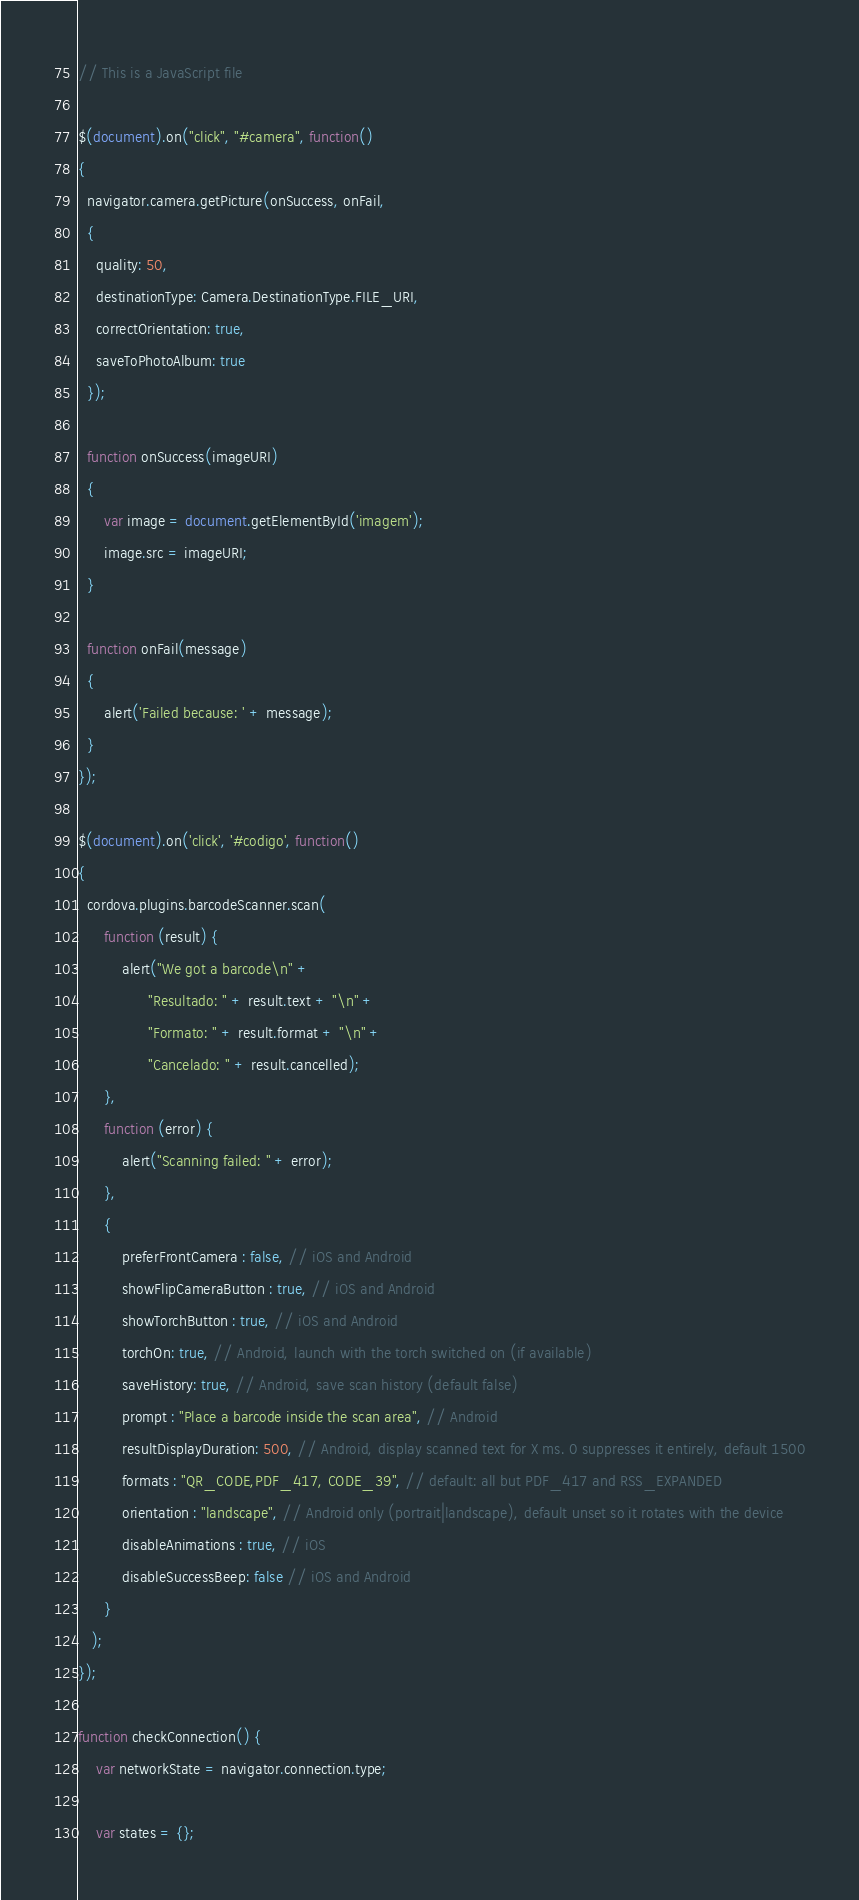Convert code to text. <code><loc_0><loc_0><loc_500><loc_500><_JavaScript_>// This is a JavaScript file

$(document).on("click", "#camera", function()
{
  navigator.camera.getPicture(onSuccess, onFail, 
  { 
    quality: 50,
    destinationType: Camera.DestinationType.FILE_URI,
    correctOrientation: true,
    saveToPhotoAlbum: true
  });

  function onSuccess(imageURI) 
  {
      var image = document.getElementById('imagem');
      image.src = imageURI;
  }

  function onFail(message) 
  {
      alert('Failed because: ' + message);
  }
});

$(document).on('click', '#codigo', function()
{
  cordova.plugins.barcodeScanner.scan(
      function (result) {
          alert("We got a barcode\n" +
                "Resultado: " + result.text + "\n" +
                "Formato: " + result.format + "\n" +
                "Cancelado: " + result.cancelled);
      },
      function (error) {
          alert("Scanning failed: " + error);
      },
      {
          preferFrontCamera : false, // iOS and Android
          showFlipCameraButton : true, // iOS and Android
          showTorchButton : true, // iOS and Android
          torchOn: true, // Android, launch with the torch switched on (if available)
          saveHistory: true, // Android, save scan history (default false)
          prompt : "Place a barcode inside the scan area", // Android
          resultDisplayDuration: 500, // Android, display scanned text for X ms. 0 suppresses it entirely, default 1500
          formats : "QR_CODE,PDF_417, CODE_39", // default: all but PDF_417 and RSS_EXPANDED
          orientation : "landscape", // Android only (portrait|landscape), default unset so it rotates with the device
          disableAnimations : true, // iOS
          disableSuccessBeep: false // iOS and Android
      }
   );
});

function checkConnection() {
    var networkState = navigator.connection.type;

    var states = {};</code> 